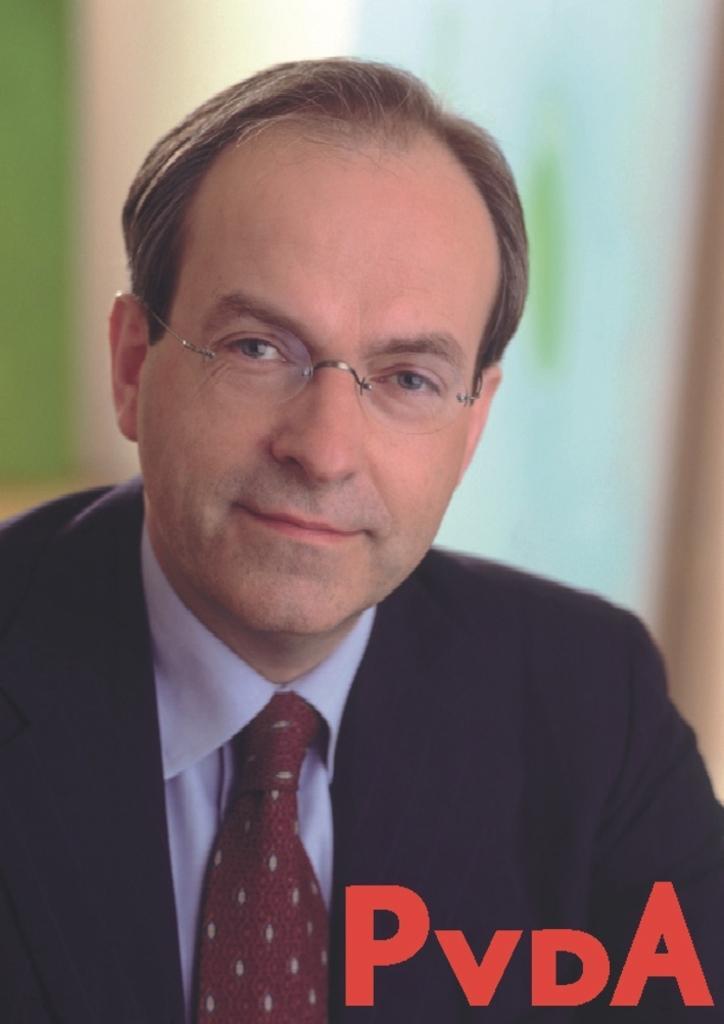Please provide a concise description of this image. In this image I can see a person wearing shirt, tie and black colored blazer. I can see the blurry background. 